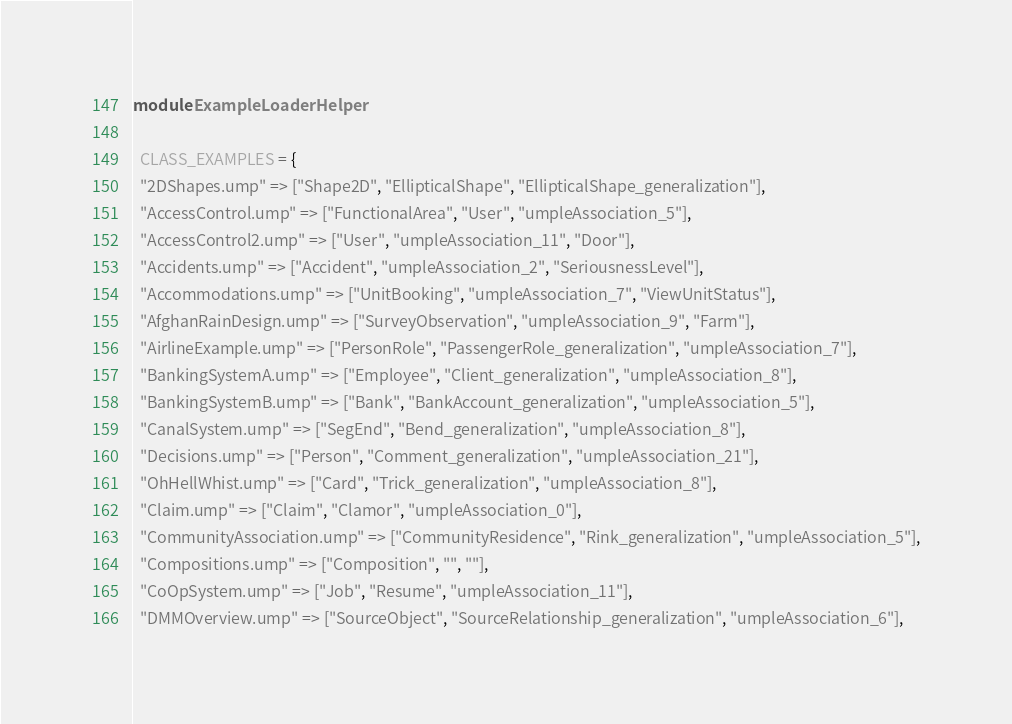<code> <loc_0><loc_0><loc_500><loc_500><_Ruby_>module ExampleLoaderHelper
  
  CLASS_EXAMPLES = {
  "2DShapes.ump" => ["Shape2D", "EllipticalShape", "EllipticalShape_generalization"],
  "AccessControl.ump" => ["FunctionalArea", "User", "umpleAssociation_5"],
  "AccessControl2.ump" => ["User", "umpleAssociation_11", "Door"],
  "Accidents.ump" => ["Accident", "umpleAssociation_2", "SeriousnessLevel"],
  "Accommodations.ump" => ["UnitBooking", "umpleAssociation_7", "ViewUnitStatus"],
  "AfghanRainDesign.ump" => ["SurveyObservation", "umpleAssociation_9", "Farm"],
  "AirlineExample.ump" => ["PersonRole", "PassengerRole_generalization", "umpleAssociation_7"],
  "BankingSystemA.ump" => ["Employee", "Client_generalization", "umpleAssociation_8"],
  "BankingSystemB.ump" => ["Bank", "BankAccount_generalization", "umpleAssociation_5"],
  "CanalSystem.ump" => ["SegEnd", "Bend_generalization", "umpleAssociation_8"],
  "Decisions.ump" => ["Person", "Comment_generalization", "umpleAssociation_21"],
  "OhHellWhist.ump" => ["Card", "Trick_generalization", "umpleAssociation_8"],
  "Claim.ump" => ["Claim", "Clamor", "umpleAssociation_0"],
  "CommunityAssociation.ump" => ["CommunityResidence", "Rink_generalization", "umpleAssociation_5"],
  "Compositions.ump" => ["Composition", "", ""],
  "CoOpSystem.ump" => ["Job", "Resume", "umpleAssociation_11"],
  "DMMOverview.ump" => ["SourceObject", "SourceRelationship_generalization", "umpleAssociation_6"],</code> 